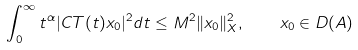Convert formula to latex. <formula><loc_0><loc_0><loc_500><loc_500>\int _ { 0 } ^ { \infty } t ^ { \alpha } | C T ( t ) x _ { 0 } | ^ { 2 } d t \leq M ^ { 2 } \| x _ { 0 } \| _ { X } ^ { 2 } , \quad x _ { 0 } \in D ( A )</formula> 